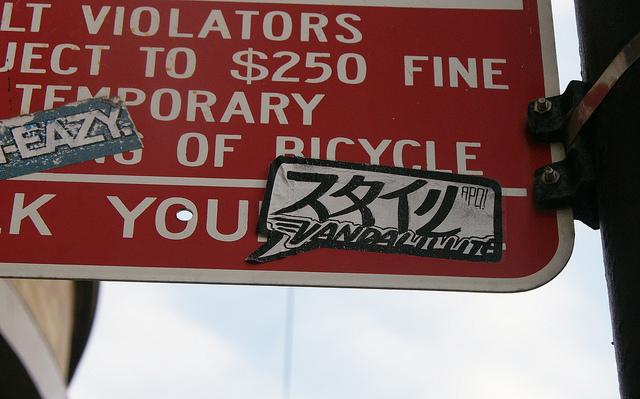Is this a street sign?
Answer briefly. Yes. What does the sticker say?
Keep it brief. Easy. Has this sign been vandalized?
Quick response, please. Yes. What is the fine for violators according to the sign?
Quick response, please. $250. What letter probably comes next on the right side?
Keep it brief. R. What is written on the red sign?
Short answer required. Fine. What does the green sticker on the sign say?
Short answer required. Easy. 